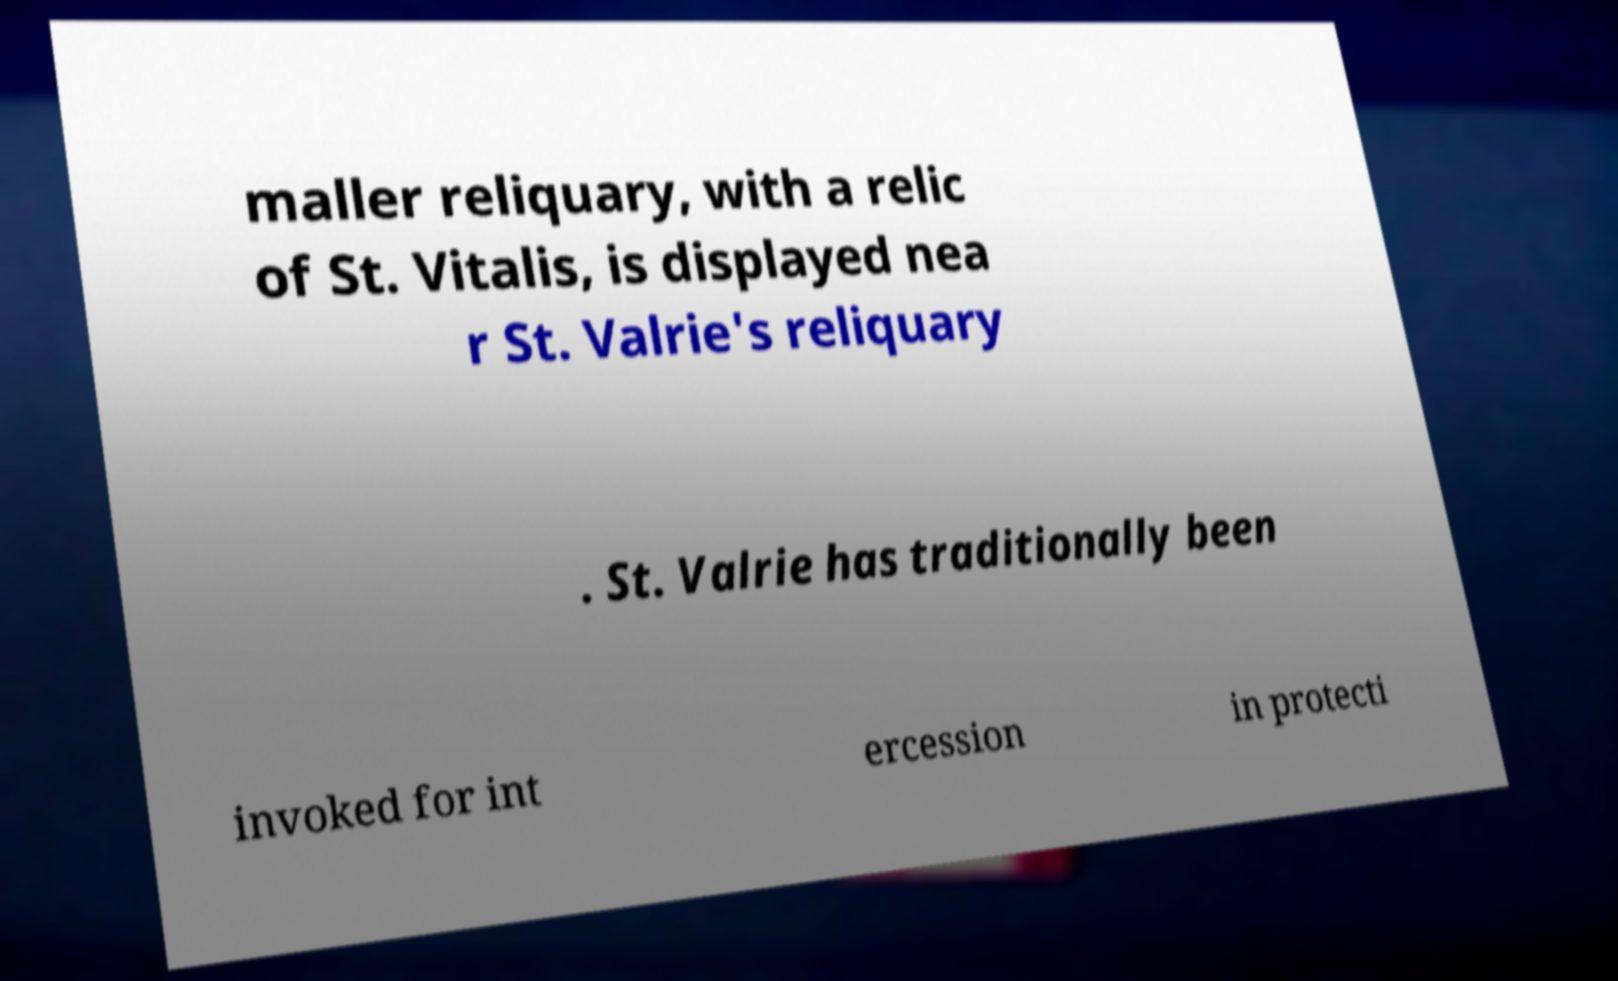Could you extract and type out the text from this image? maller reliquary, with a relic of St. Vitalis, is displayed nea r St. Valrie's reliquary . St. Valrie has traditionally been invoked for int ercession in protecti 